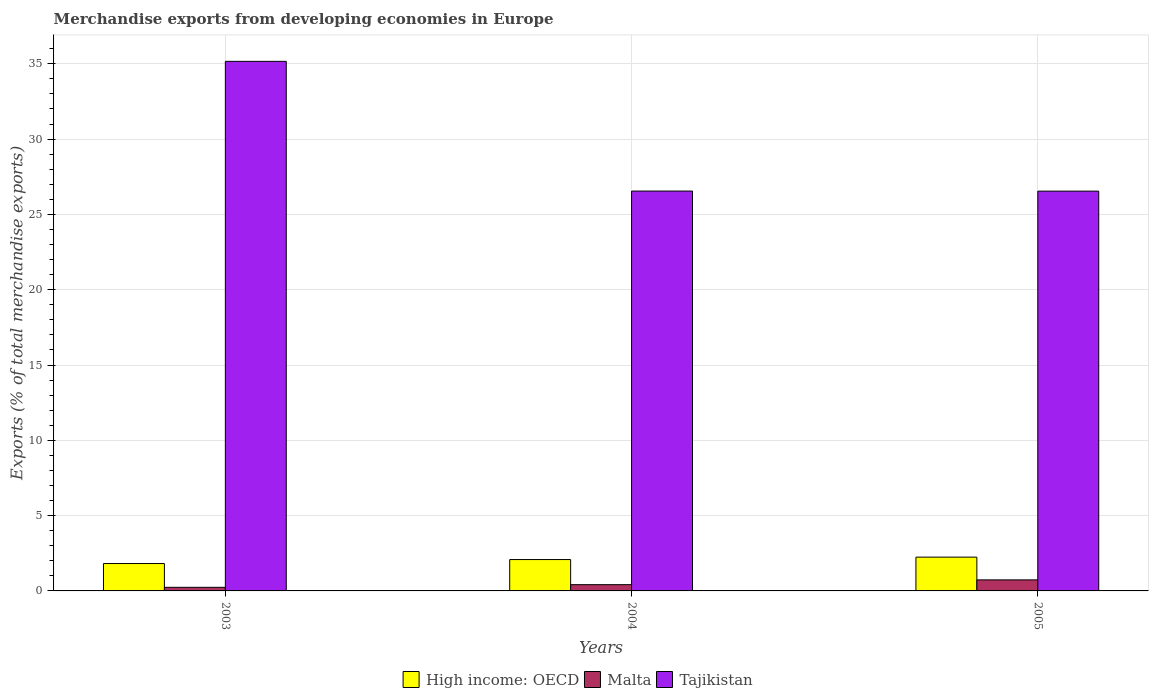How many different coloured bars are there?
Your response must be concise. 3. Are the number of bars per tick equal to the number of legend labels?
Provide a short and direct response. Yes. How many bars are there on the 3rd tick from the left?
Provide a succinct answer. 3. How many bars are there on the 3rd tick from the right?
Keep it short and to the point. 3. What is the percentage of total merchandise exports in High income: OECD in 2005?
Your response must be concise. 2.24. Across all years, what is the maximum percentage of total merchandise exports in High income: OECD?
Offer a terse response. 2.24. Across all years, what is the minimum percentage of total merchandise exports in Malta?
Offer a very short reply. 0.24. What is the total percentage of total merchandise exports in High income: OECD in the graph?
Give a very brief answer. 6.14. What is the difference between the percentage of total merchandise exports in Tajikistan in 2003 and that in 2005?
Your answer should be very brief. 8.62. What is the difference between the percentage of total merchandise exports in High income: OECD in 2005 and the percentage of total merchandise exports in Malta in 2004?
Offer a terse response. 1.83. What is the average percentage of total merchandise exports in High income: OECD per year?
Make the answer very short. 2.05. In the year 2005, what is the difference between the percentage of total merchandise exports in High income: OECD and percentage of total merchandise exports in Tajikistan?
Your answer should be very brief. -24.3. What is the ratio of the percentage of total merchandise exports in Malta in 2003 to that in 2005?
Your answer should be very brief. 0.33. Is the percentage of total merchandise exports in Tajikistan in 2003 less than that in 2004?
Give a very brief answer. No. What is the difference between the highest and the second highest percentage of total merchandise exports in High income: OECD?
Your answer should be compact. 0.16. What is the difference between the highest and the lowest percentage of total merchandise exports in Malta?
Your answer should be very brief. 0.49. In how many years, is the percentage of total merchandise exports in Malta greater than the average percentage of total merchandise exports in Malta taken over all years?
Your answer should be very brief. 1. Is the sum of the percentage of total merchandise exports in Malta in 2004 and 2005 greater than the maximum percentage of total merchandise exports in Tajikistan across all years?
Your answer should be compact. No. What does the 1st bar from the left in 2003 represents?
Ensure brevity in your answer.  High income: OECD. What does the 2nd bar from the right in 2004 represents?
Make the answer very short. Malta. How many bars are there?
Offer a very short reply. 9. How many years are there in the graph?
Your answer should be compact. 3. Are the values on the major ticks of Y-axis written in scientific E-notation?
Your response must be concise. No. Does the graph contain any zero values?
Offer a terse response. No. Where does the legend appear in the graph?
Offer a very short reply. Bottom center. How are the legend labels stacked?
Offer a terse response. Horizontal. What is the title of the graph?
Give a very brief answer. Merchandise exports from developing economies in Europe. What is the label or title of the Y-axis?
Ensure brevity in your answer.  Exports (% of total merchandise exports). What is the Exports (% of total merchandise exports) in High income: OECD in 2003?
Make the answer very short. 1.82. What is the Exports (% of total merchandise exports) in Malta in 2003?
Your answer should be compact. 0.24. What is the Exports (% of total merchandise exports) of Tajikistan in 2003?
Ensure brevity in your answer.  35.16. What is the Exports (% of total merchandise exports) in High income: OECD in 2004?
Provide a succinct answer. 2.08. What is the Exports (% of total merchandise exports) in Malta in 2004?
Offer a very short reply. 0.42. What is the Exports (% of total merchandise exports) of Tajikistan in 2004?
Ensure brevity in your answer.  26.55. What is the Exports (% of total merchandise exports) in High income: OECD in 2005?
Make the answer very short. 2.24. What is the Exports (% of total merchandise exports) of Malta in 2005?
Your answer should be compact. 0.73. What is the Exports (% of total merchandise exports) of Tajikistan in 2005?
Your response must be concise. 26.54. Across all years, what is the maximum Exports (% of total merchandise exports) of High income: OECD?
Your answer should be very brief. 2.24. Across all years, what is the maximum Exports (% of total merchandise exports) of Malta?
Give a very brief answer. 0.73. Across all years, what is the maximum Exports (% of total merchandise exports) in Tajikistan?
Provide a succinct answer. 35.16. Across all years, what is the minimum Exports (% of total merchandise exports) of High income: OECD?
Provide a succinct answer. 1.82. Across all years, what is the minimum Exports (% of total merchandise exports) of Malta?
Your answer should be compact. 0.24. Across all years, what is the minimum Exports (% of total merchandise exports) of Tajikistan?
Provide a short and direct response. 26.54. What is the total Exports (% of total merchandise exports) in High income: OECD in the graph?
Make the answer very short. 6.14. What is the total Exports (% of total merchandise exports) in Malta in the graph?
Your response must be concise. 1.39. What is the total Exports (% of total merchandise exports) in Tajikistan in the graph?
Provide a succinct answer. 88.25. What is the difference between the Exports (% of total merchandise exports) in High income: OECD in 2003 and that in 2004?
Ensure brevity in your answer.  -0.26. What is the difference between the Exports (% of total merchandise exports) in Malta in 2003 and that in 2004?
Provide a short and direct response. -0.18. What is the difference between the Exports (% of total merchandise exports) in Tajikistan in 2003 and that in 2004?
Provide a short and direct response. 8.61. What is the difference between the Exports (% of total merchandise exports) of High income: OECD in 2003 and that in 2005?
Give a very brief answer. -0.42. What is the difference between the Exports (% of total merchandise exports) in Malta in 2003 and that in 2005?
Your answer should be very brief. -0.49. What is the difference between the Exports (% of total merchandise exports) in Tajikistan in 2003 and that in 2005?
Provide a short and direct response. 8.62. What is the difference between the Exports (% of total merchandise exports) in High income: OECD in 2004 and that in 2005?
Provide a short and direct response. -0.16. What is the difference between the Exports (% of total merchandise exports) of Malta in 2004 and that in 2005?
Ensure brevity in your answer.  -0.32. What is the difference between the Exports (% of total merchandise exports) of Tajikistan in 2004 and that in 2005?
Ensure brevity in your answer.  0.01. What is the difference between the Exports (% of total merchandise exports) of High income: OECD in 2003 and the Exports (% of total merchandise exports) of Malta in 2004?
Your answer should be very brief. 1.4. What is the difference between the Exports (% of total merchandise exports) in High income: OECD in 2003 and the Exports (% of total merchandise exports) in Tajikistan in 2004?
Offer a very short reply. -24.73. What is the difference between the Exports (% of total merchandise exports) in Malta in 2003 and the Exports (% of total merchandise exports) in Tajikistan in 2004?
Offer a terse response. -26.31. What is the difference between the Exports (% of total merchandise exports) of High income: OECD in 2003 and the Exports (% of total merchandise exports) of Malta in 2005?
Your answer should be compact. 1.09. What is the difference between the Exports (% of total merchandise exports) of High income: OECD in 2003 and the Exports (% of total merchandise exports) of Tajikistan in 2005?
Offer a terse response. -24.72. What is the difference between the Exports (% of total merchandise exports) in Malta in 2003 and the Exports (% of total merchandise exports) in Tajikistan in 2005?
Provide a succinct answer. -26.3. What is the difference between the Exports (% of total merchandise exports) in High income: OECD in 2004 and the Exports (% of total merchandise exports) in Malta in 2005?
Your answer should be compact. 1.35. What is the difference between the Exports (% of total merchandise exports) in High income: OECD in 2004 and the Exports (% of total merchandise exports) in Tajikistan in 2005?
Your answer should be very brief. -24.46. What is the difference between the Exports (% of total merchandise exports) of Malta in 2004 and the Exports (% of total merchandise exports) of Tajikistan in 2005?
Your response must be concise. -26.13. What is the average Exports (% of total merchandise exports) of High income: OECD per year?
Keep it short and to the point. 2.05. What is the average Exports (% of total merchandise exports) in Malta per year?
Ensure brevity in your answer.  0.46. What is the average Exports (% of total merchandise exports) in Tajikistan per year?
Ensure brevity in your answer.  29.42. In the year 2003, what is the difference between the Exports (% of total merchandise exports) in High income: OECD and Exports (% of total merchandise exports) in Malta?
Offer a very short reply. 1.58. In the year 2003, what is the difference between the Exports (% of total merchandise exports) of High income: OECD and Exports (% of total merchandise exports) of Tajikistan?
Provide a succinct answer. -33.34. In the year 2003, what is the difference between the Exports (% of total merchandise exports) in Malta and Exports (% of total merchandise exports) in Tajikistan?
Ensure brevity in your answer.  -34.92. In the year 2004, what is the difference between the Exports (% of total merchandise exports) of High income: OECD and Exports (% of total merchandise exports) of Malta?
Your answer should be very brief. 1.67. In the year 2004, what is the difference between the Exports (% of total merchandise exports) of High income: OECD and Exports (% of total merchandise exports) of Tajikistan?
Your answer should be compact. -24.47. In the year 2004, what is the difference between the Exports (% of total merchandise exports) of Malta and Exports (% of total merchandise exports) of Tajikistan?
Ensure brevity in your answer.  -26.13. In the year 2005, what is the difference between the Exports (% of total merchandise exports) of High income: OECD and Exports (% of total merchandise exports) of Malta?
Give a very brief answer. 1.51. In the year 2005, what is the difference between the Exports (% of total merchandise exports) of High income: OECD and Exports (% of total merchandise exports) of Tajikistan?
Keep it short and to the point. -24.3. In the year 2005, what is the difference between the Exports (% of total merchandise exports) of Malta and Exports (% of total merchandise exports) of Tajikistan?
Offer a terse response. -25.81. What is the ratio of the Exports (% of total merchandise exports) of High income: OECD in 2003 to that in 2004?
Your answer should be compact. 0.87. What is the ratio of the Exports (% of total merchandise exports) in Malta in 2003 to that in 2004?
Keep it short and to the point. 0.58. What is the ratio of the Exports (% of total merchandise exports) of Tajikistan in 2003 to that in 2004?
Make the answer very short. 1.32. What is the ratio of the Exports (% of total merchandise exports) in High income: OECD in 2003 to that in 2005?
Ensure brevity in your answer.  0.81. What is the ratio of the Exports (% of total merchandise exports) in Malta in 2003 to that in 2005?
Your answer should be very brief. 0.33. What is the ratio of the Exports (% of total merchandise exports) of Tajikistan in 2003 to that in 2005?
Provide a succinct answer. 1.32. What is the ratio of the Exports (% of total merchandise exports) in High income: OECD in 2004 to that in 2005?
Your answer should be compact. 0.93. What is the ratio of the Exports (% of total merchandise exports) in Malta in 2004 to that in 2005?
Offer a very short reply. 0.57. What is the difference between the highest and the second highest Exports (% of total merchandise exports) in High income: OECD?
Ensure brevity in your answer.  0.16. What is the difference between the highest and the second highest Exports (% of total merchandise exports) of Malta?
Give a very brief answer. 0.32. What is the difference between the highest and the second highest Exports (% of total merchandise exports) in Tajikistan?
Your answer should be compact. 8.61. What is the difference between the highest and the lowest Exports (% of total merchandise exports) of High income: OECD?
Make the answer very short. 0.42. What is the difference between the highest and the lowest Exports (% of total merchandise exports) of Malta?
Offer a very short reply. 0.49. What is the difference between the highest and the lowest Exports (% of total merchandise exports) of Tajikistan?
Your answer should be very brief. 8.62. 